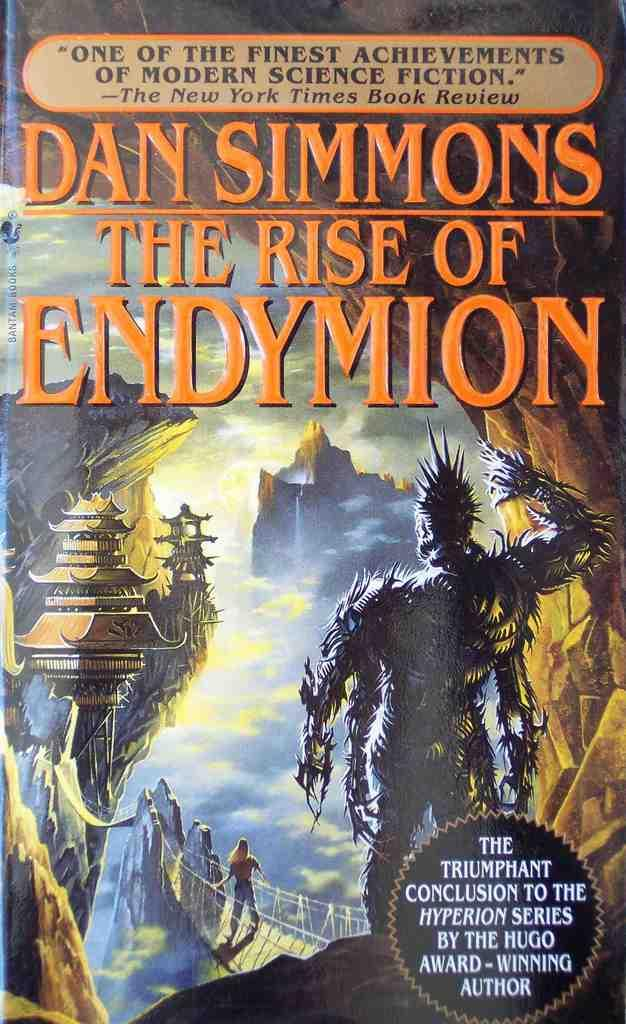<image>
Describe the image concisely. a cover of The Rise of Endymion by Dan Simmons 